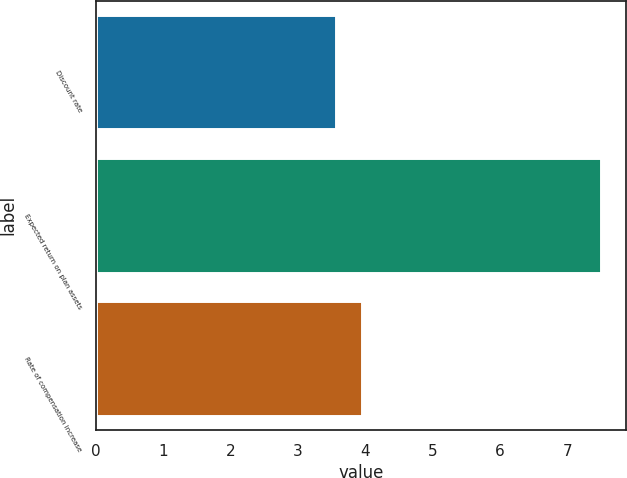Convert chart. <chart><loc_0><loc_0><loc_500><loc_500><bar_chart><fcel>Discount rate<fcel>Expected return on plan assets<fcel>Rate of compensation increase<nl><fcel>3.56<fcel>7.5<fcel>3.95<nl></chart> 